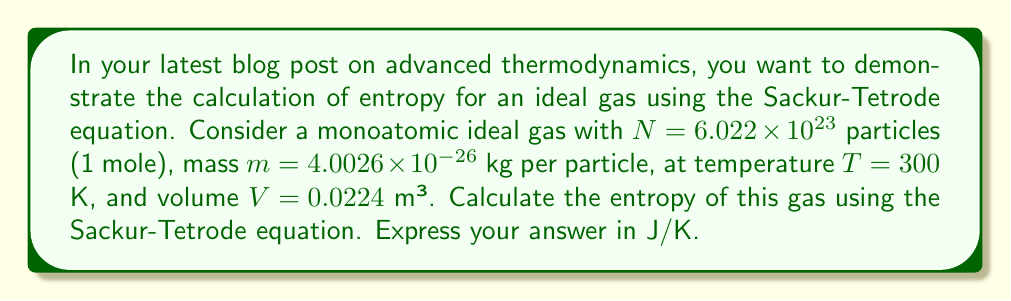Can you solve this math problem? To calculate the entropy of an ideal gas using the Sackur-Tetrode equation, we'll follow these steps:

1) The Sackur-Tetrode equation for entropy is:

   $$S = Nk_B \left[\ln\left(\frac{V}{N}\left(\frac{4\pi mU}{3Nh^2}\right)^{3/2}\right) + \frac{5}{2}\right]$$

   where $k_B$ is Boltzmann's constant, $h$ is Planck's constant, and $U$ is the internal energy.

2) For a monoatomic ideal gas, $U = \frac{3}{2}Nk_BT$.

3) Let's substitute the known values:
   $N = 6.022 \times 10^{23}$
   $m = 4.0026 \times 10^{-26}$ kg
   $T = 300$ K
   $V = 0.0224$ m³
   $k_B = 1.380649 \times 10^{-23}$ J/K
   $h = 6.62607015 \times 10^{-34}$ J⋅s

4) First, calculate $U$:
   $$U = \frac{3}{2}Nk_BT = \frac{3}{2} \times 6.022 \times 10^{23} \times 1.380649 \times 10^{-23} \times 300 = 3743.04 \text{ J}$$

5) Now, let's substitute everything into the Sackur-Tetrode equation:

   $$S = 6.022 \times 10^{23} \times 1.380649 \times 10^{-23} \times \left[\ln\left(\frac{0.0224}{6.022 \times 10^{23}}\left(\frac{4\pi \times 4.0026 \times 10^{-26} \times 3743.04}{3 \times 6.022 \times 10^{23} \times (6.62607015 \times 10^{-34})^2}\right)^{3/2}\right) + \frac{5}{2}\right]$$

6) Simplify and calculate:
   $$S = 8.314 \times [\ln(1.6439 \times 10^{31}) + 2.5] = 8.314 \times [72.1408 + 2.5] = 620.1 \text{ J/K}$$
Answer: $620.1$ J/K 